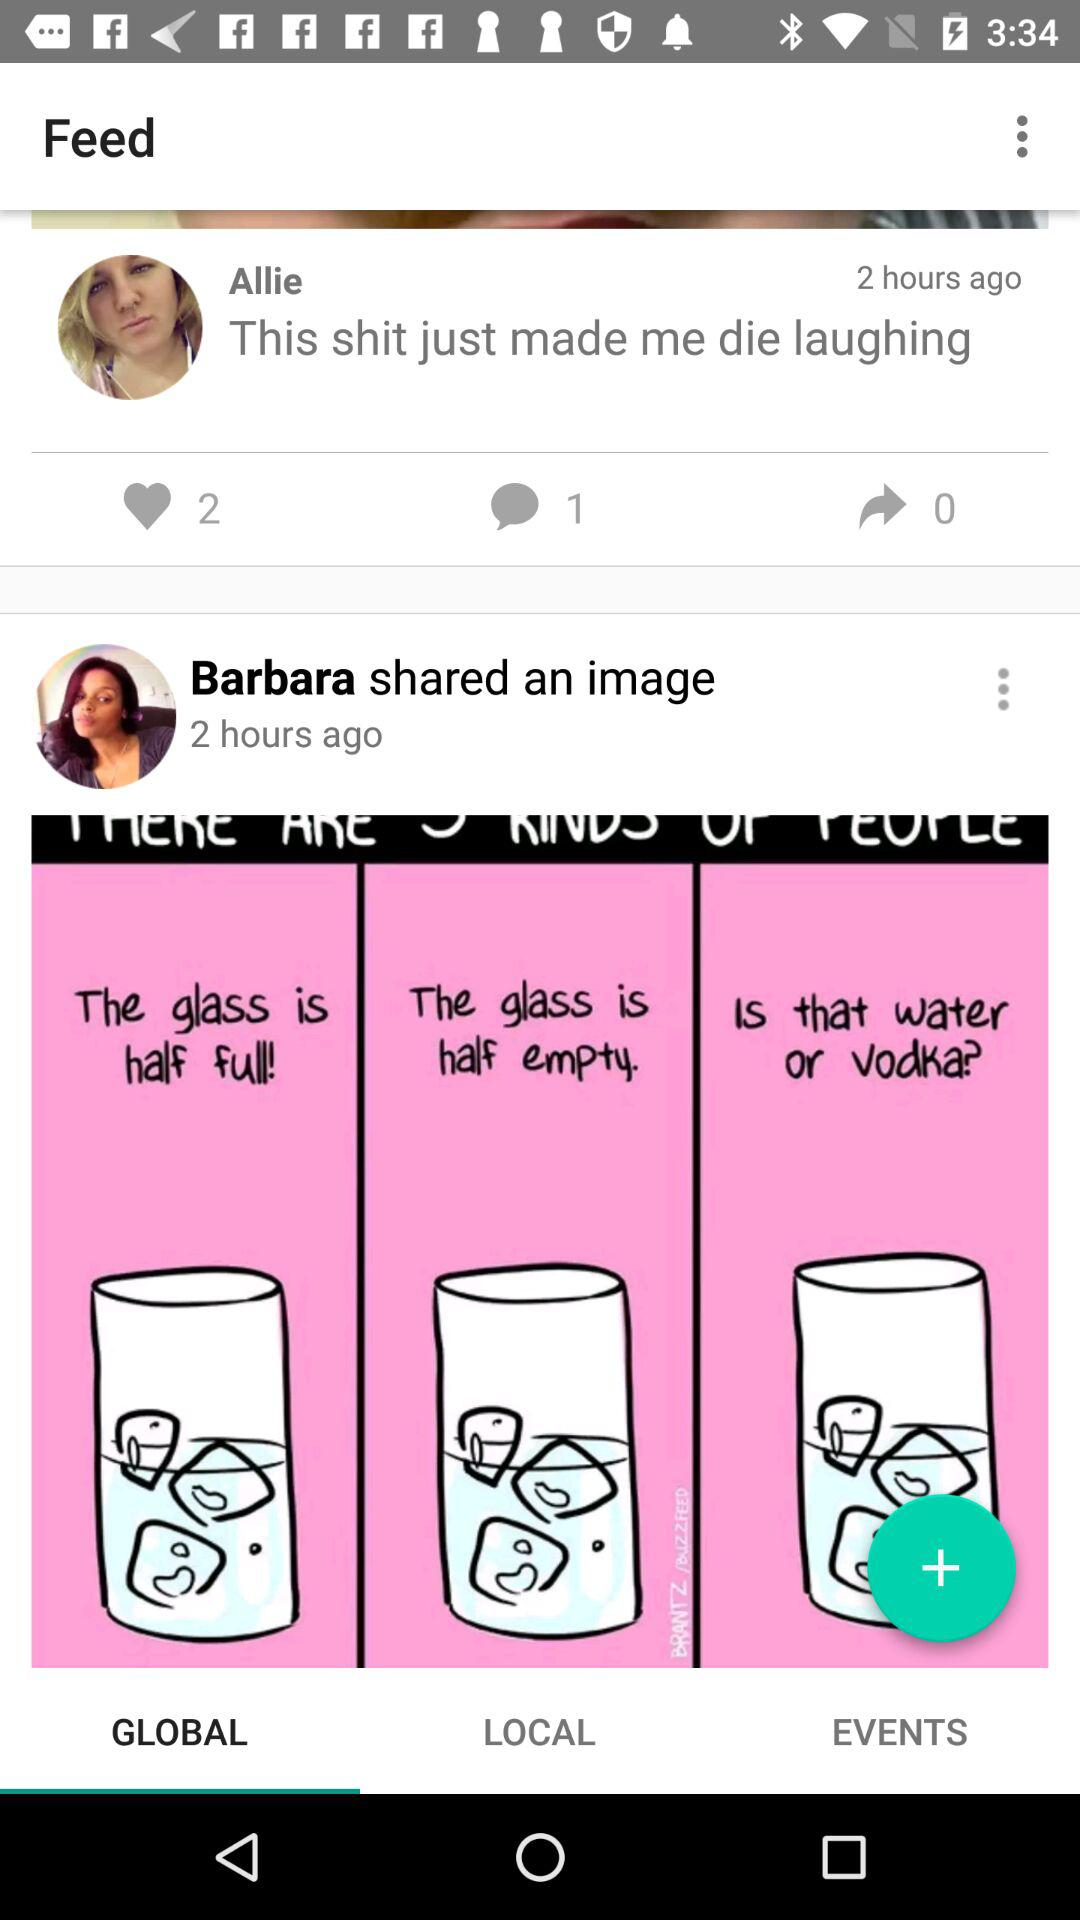How many comments are there on Allie's post? There is 1 comment on Allie's post. 